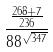<formula> <loc_0><loc_0><loc_500><loc_500>\frac { \frac { 2 6 8 + 7 } { 2 3 6 } } { 8 8 ^ { \sqrt { 3 4 7 } } }</formula> 